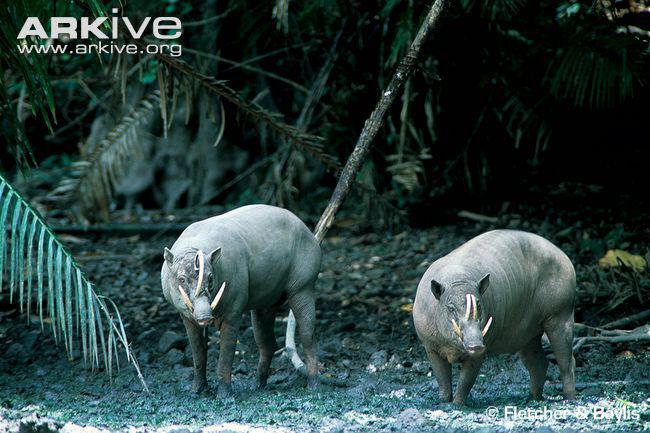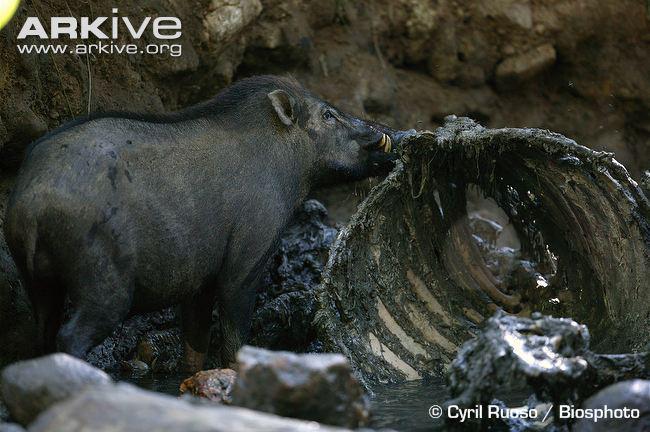The first image is the image on the left, the second image is the image on the right. Evaluate the accuracy of this statement regarding the images: "a lone wartgog is standing in the water". Is it true? Answer yes or no. No. The first image is the image on the left, the second image is the image on the right. For the images shown, is this caption "There are two pigs." true? Answer yes or no. No. 